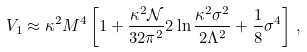<formula> <loc_0><loc_0><loc_500><loc_500>V _ { 1 } \approx \kappa ^ { 2 } M ^ { 4 } \left [ 1 + \frac { \kappa ^ { 2 } \mathcal { N } } { 3 2 \pi ^ { 2 } } 2 \ln \frac { \kappa ^ { 2 } \sigma ^ { 2 } } { 2 \Lambda ^ { 2 } } + \frac { 1 } { 8 } \sigma ^ { 4 } \right ] \, ,</formula> 